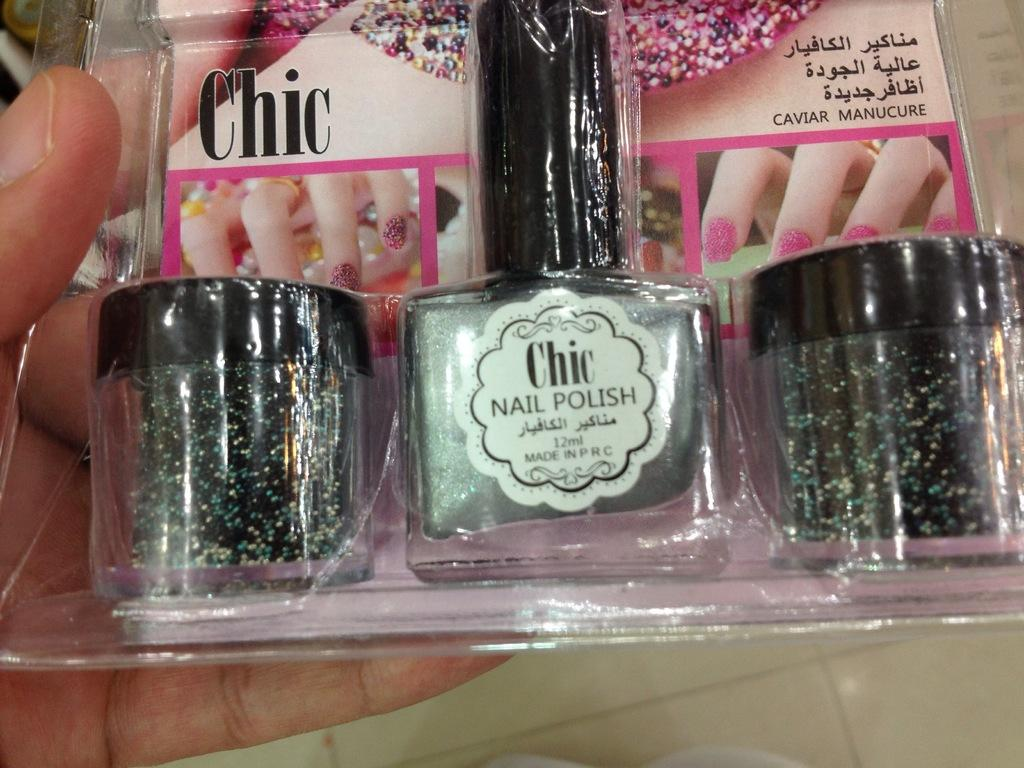Provide a one-sentence caption for the provided image. A package has a bottle of Chic brand nail polish in it. 